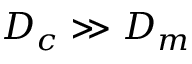Convert formula to latex. <formula><loc_0><loc_0><loc_500><loc_500>D _ { c } \gg D _ { m }</formula> 